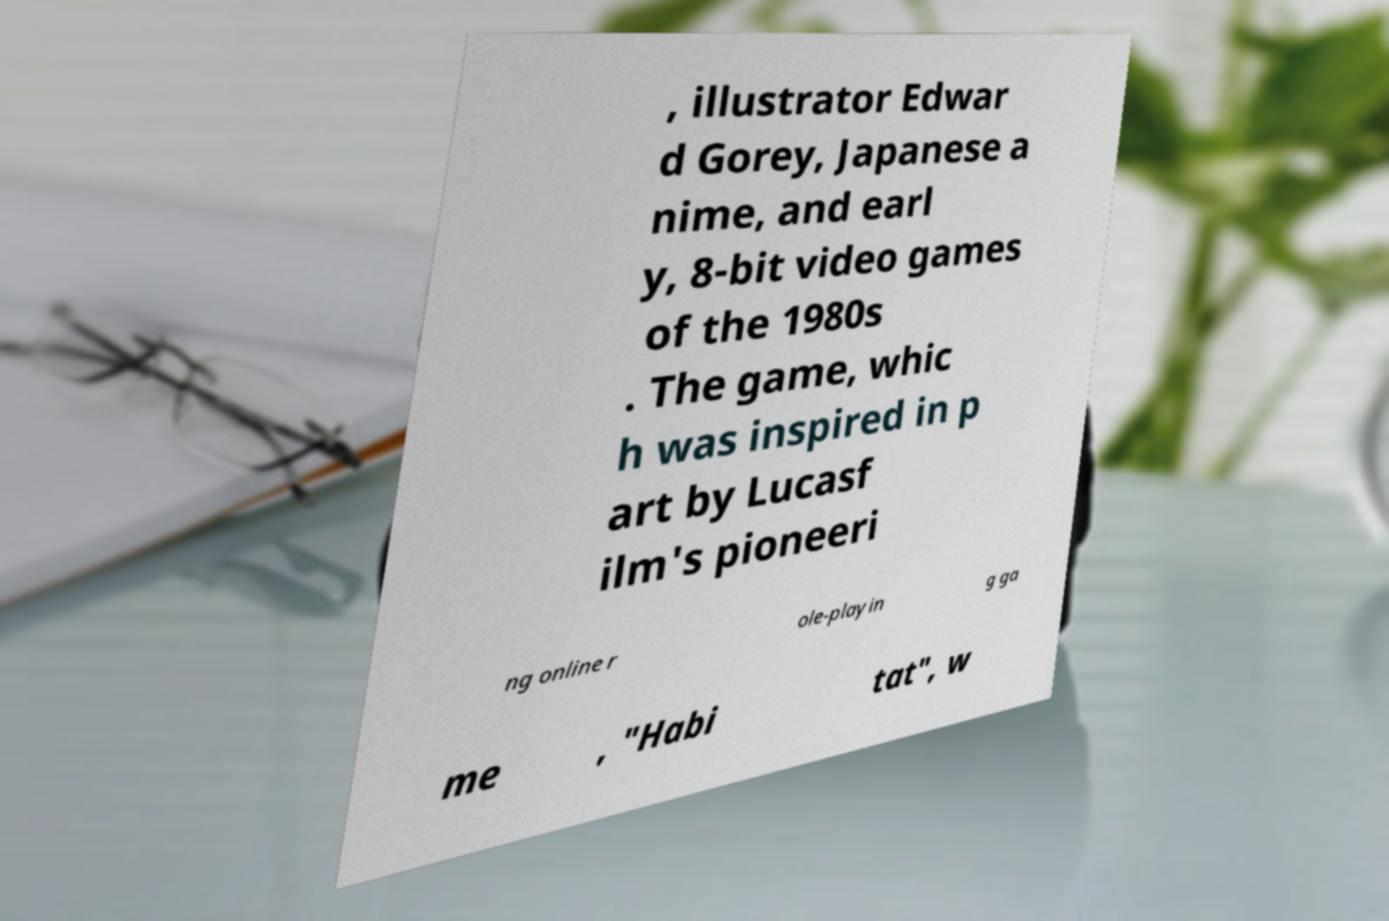Can you read and provide the text displayed in the image?This photo seems to have some interesting text. Can you extract and type it out for me? , illustrator Edwar d Gorey, Japanese a nime, and earl y, 8-bit video games of the 1980s . The game, whic h was inspired in p art by Lucasf ilm's pioneeri ng online r ole-playin g ga me , "Habi tat", w 